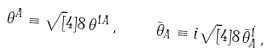<formula> <loc_0><loc_0><loc_500><loc_500>\theta ^ { A } \equiv \sqrt { [ } 4 ] { 8 } \, \theta ^ { 1 A } \, , \quad \bar { \theta } _ { A } \equiv i \sqrt { [ } 4 ] { 8 } \, \bar { \theta } ^ { \dot { 1 } } _ { A } \, ,</formula> 